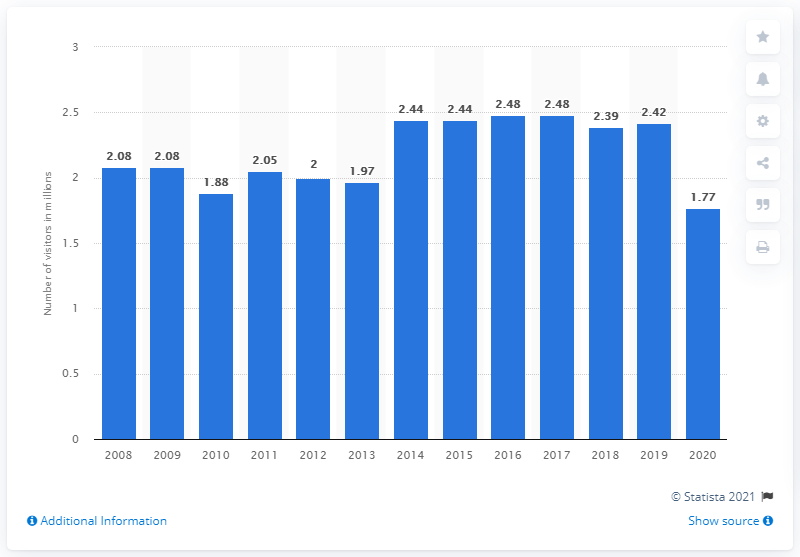Indicate a few pertinent items in this graphic. In 2020, the number of people who visited Rock Creek Park was 1.77 million. 